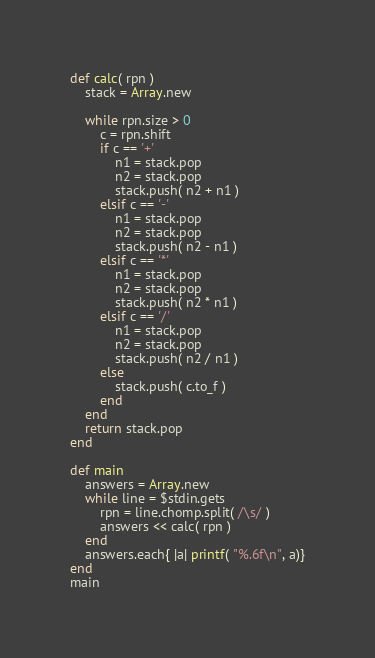Convert code to text. <code><loc_0><loc_0><loc_500><loc_500><_Ruby_>def calc( rpn )
	stack = Array.new

	while rpn.size > 0
		c = rpn.shift
		if c == '+'
			n1 = stack.pop
			n2 = stack.pop
			stack.push( n2 + n1 )
		elsif c == '-'
			n1 = stack.pop
			n2 = stack.pop
			stack.push( n2 - n1 )
		elsif c == '*'
			n1 = stack.pop
			n2 = stack.pop
			stack.push( n2 * n1 )
		elsif c == '/'
			n1 = stack.pop
			n2 = stack.pop
			stack.push( n2 / n1 )
		else
			stack.push( c.to_f )
		end
	end
	return stack.pop
end

def main
	answers = Array.new
	while line = $stdin.gets
		rpn = line.chomp.split( /\s/ )
		answers << calc( rpn )
	end
	answers.each{ |a| printf( "%.6f\n", a)}
end
main
</code> 